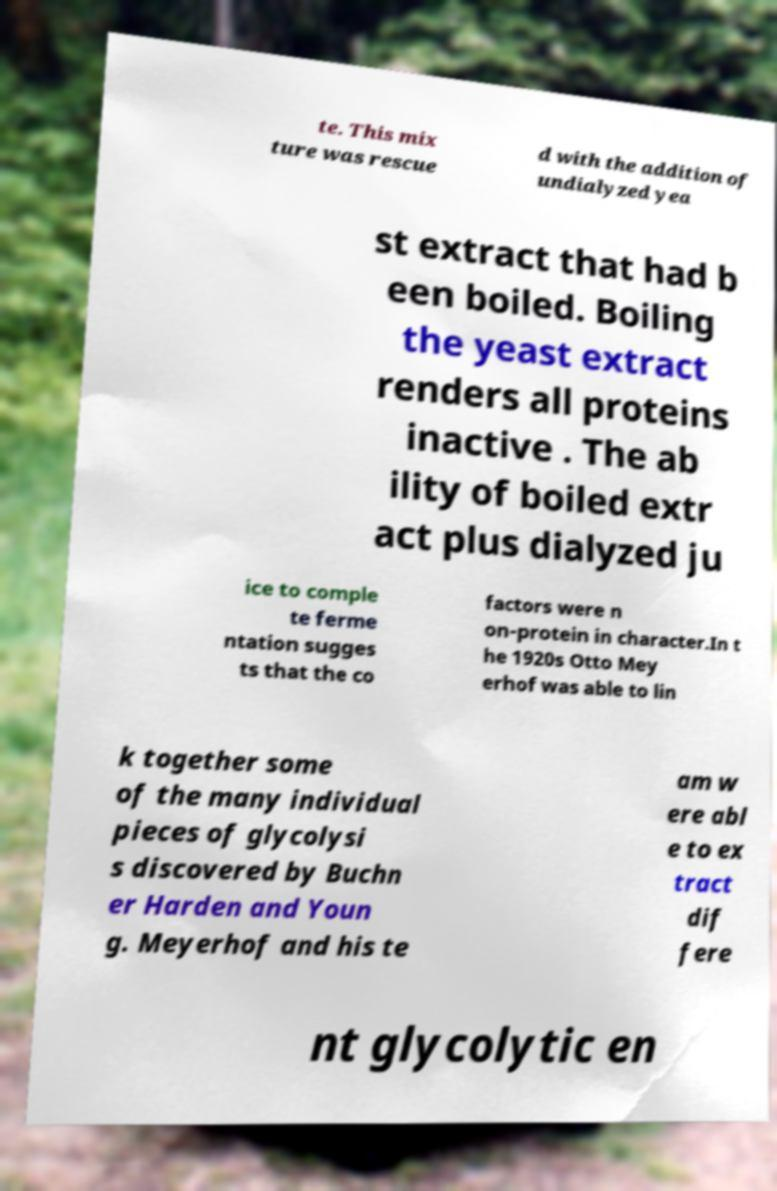There's text embedded in this image that I need extracted. Can you transcribe it verbatim? te. This mix ture was rescue d with the addition of undialyzed yea st extract that had b een boiled. Boiling the yeast extract renders all proteins inactive . The ab ility of boiled extr act plus dialyzed ju ice to comple te ferme ntation sugges ts that the co factors were n on-protein in character.In t he 1920s Otto Mey erhof was able to lin k together some of the many individual pieces of glycolysi s discovered by Buchn er Harden and Youn g. Meyerhof and his te am w ere abl e to ex tract dif fere nt glycolytic en 